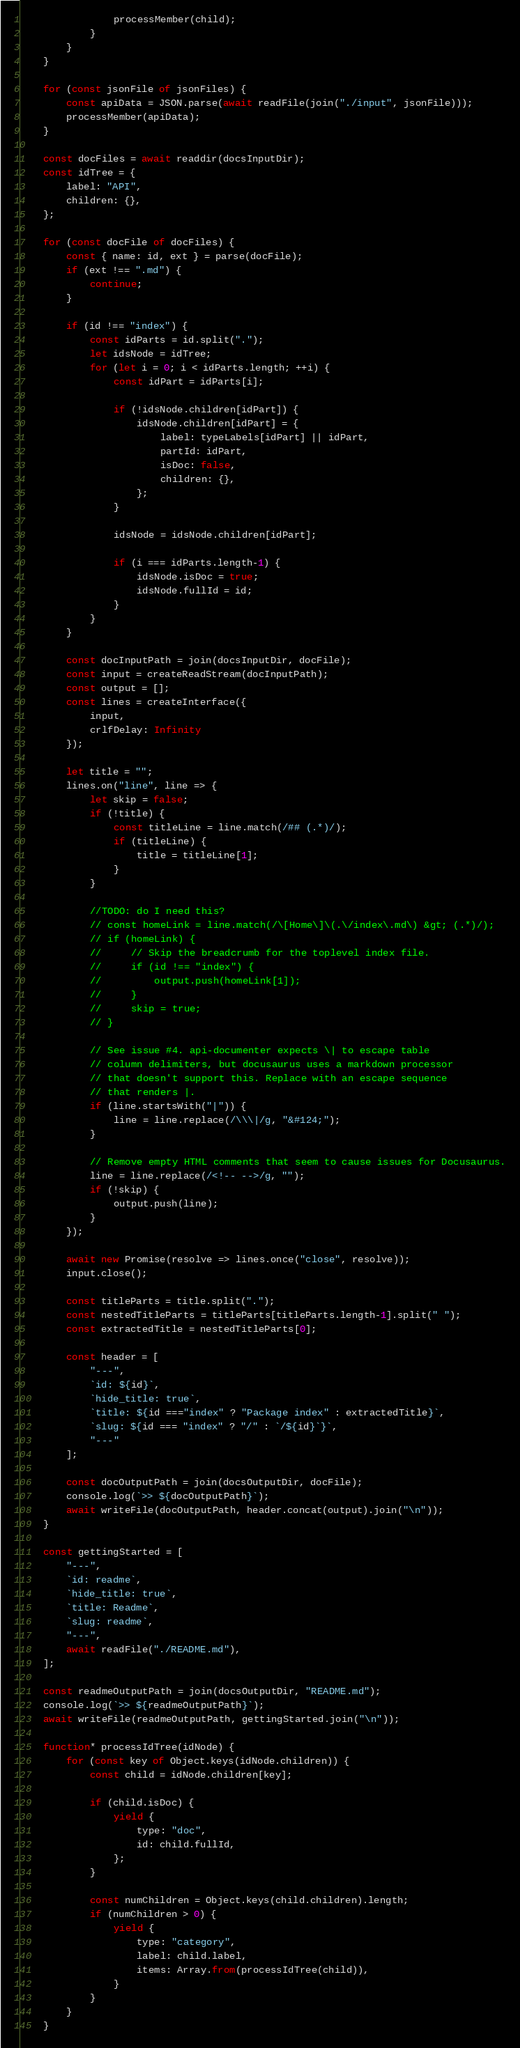Convert code to text. <code><loc_0><loc_0><loc_500><loc_500><_JavaScript_>                processMember(child);
            }
        }
    }

    for (const jsonFile of jsonFiles) {
        const apiData = JSON.parse(await readFile(join("./input", jsonFile)));
        processMember(apiData);
    }

    const docFiles = await readdir(docsInputDir);
    const idTree = {
        label: "API",
        children: {},
    };

    for (const docFile of docFiles) {
        const { name: id, ext } = parse(docFile);
        if (ext !== ".md") {
            continue;
        }

        if (id !== "index") {
            const idParts = id.split(".");
            let idsNode = idTree;
            for (let i = 0; i < idParts.length; ++i) {
                const idPart = idParts[i];

                if (!idsNode.children[idPart]) {
                    idsNode.children[idPart] = {
                        label: typeLabels[idPart] || idPart,
                        partId: idPart,
                        isDoc: false,
                        children: {},
                    };
                }

                idsNode = idsNode.children[idPart];

                if (i === idParts.length-1) {
                    idsNode.isDoc = true;
                    idsNode.fullId = id;
                }
            }
        }

        const docInputPath = join(docsInputDir, docFile);
        const input = createReadStream(docInputPath);
        const output = [];
        const lines = createInterface({
            input,
            crlfDelay: Infinity
        });

        let title = "";
        lines.on("line", line => {
            let skip = false;
            if (!title) {
                const titleLine = line.match(/## (.*)/);
                if (titleLine) {
                    title = titleLine[1];
                }
            }

            //TODO: do I need this?
            // const homeLink = line.match(/\[Home\]\(.\/index\.md\) &gt; (.*)/);
            // if (homeLink) {
            //     // Skip the breadcrumb for the toplevel index file.
            //     if (id !== "index") {
            //         output.push(homeLink[1]);
            //     }
            //     skip = true;
            // }

            // See issue #4. api-documenter expects \| to escape table
            // column delimiters, but docusaurus uses a markdown processor
            // that doesn't support this. Replace with an escape sequence
            // that renders |.
            if (line.startsWith("|")) {
                line = line.replace(/\\\|/g, "&#124;");
            }

            // Remove empty HTML comments that seem to cause issues for Docusaurus.
            line = line.replace(/<!-- -->/g, "");
            if (!skip) {
                output.push(line);
            }
        });

        await new Promise(resolve => lines.once("close", resolve));
        input.close();

        const titleParts = title.split(".");
        const nestedTitleParts = titleParts[titleParts.length-1].split(" ");
        const extractedTitle = nestedTitleParts[0];

        const header = [
            "---",
            `id: ${id}`,
            `hide_title: true`,
            `title: ${id ==="index" ? "Package index" : extractedTitle}`,
            `slug: ${id === "index" ? "/" : `/${id}`}`,
            "---"
        ];

        const docOutputPath = join(docsOutputDir, docFile);
        console.log(`>> ${docOutputPath}`);
        await writeFile(docOutputPath, header.concat(output).join("\n"));
    }

    const gettingStarted = [
        "---",
        `id: readme`,
        `hide_title: true`,
        `title: Readme`,
        `slug: readme`,
        "---",
        await readFile("./README.md"),
    ];

    const readmeOutputPath = join(docsOutputDir, "README.md");
    console.log(`>> ${readmeOutputPath}`);
    await writeFile(readmeOutputPath, gettingStarted.join("\n"));

    function* processIdTree(idNode) {
        for (const key of Object.keys(idNode.children)) {
            const child = idNode.children[key];

            if (child.isDoc) {
                yield {
                    type: "doc",
                    id: child.fullId,
                };
            }

            const numChildren = Object.keys(child.children).length;
            if (numChildren > 0) {
                yield {
                    type: "category",
                    label: child.label,
                    items: Array.from(processIdTree(child)),
                }
            }
        }
    }
</code> 